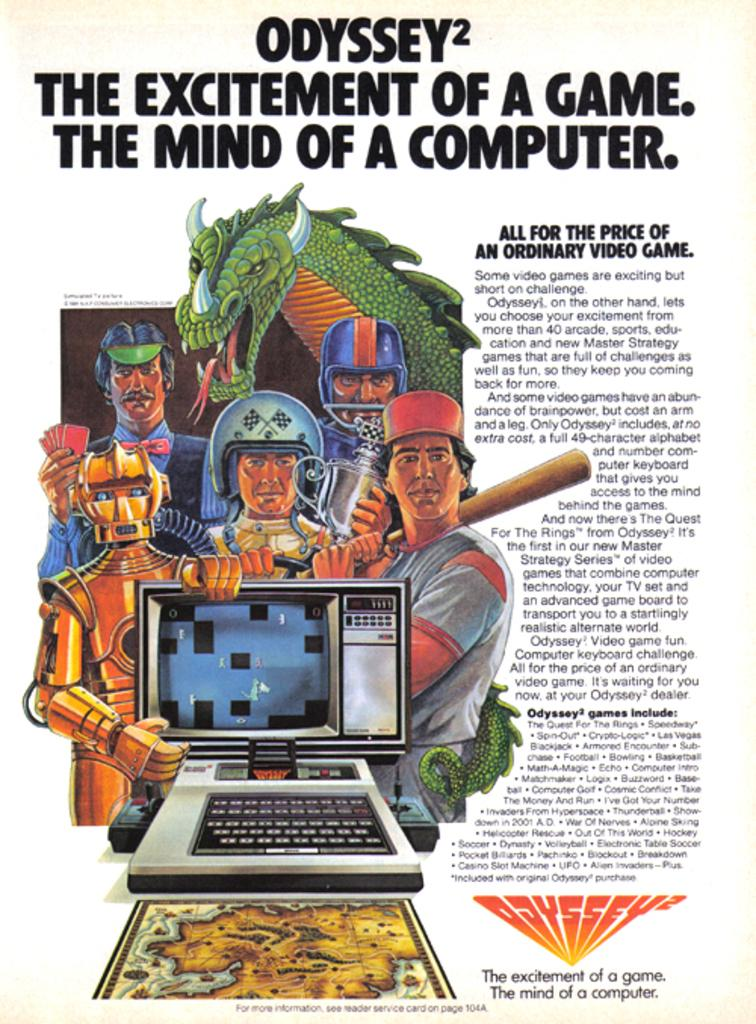<image>
Give a short and clear explanation of the subsequent image. A print ad for the Odyssey 2 computer with several fictional character standing around a computer. 